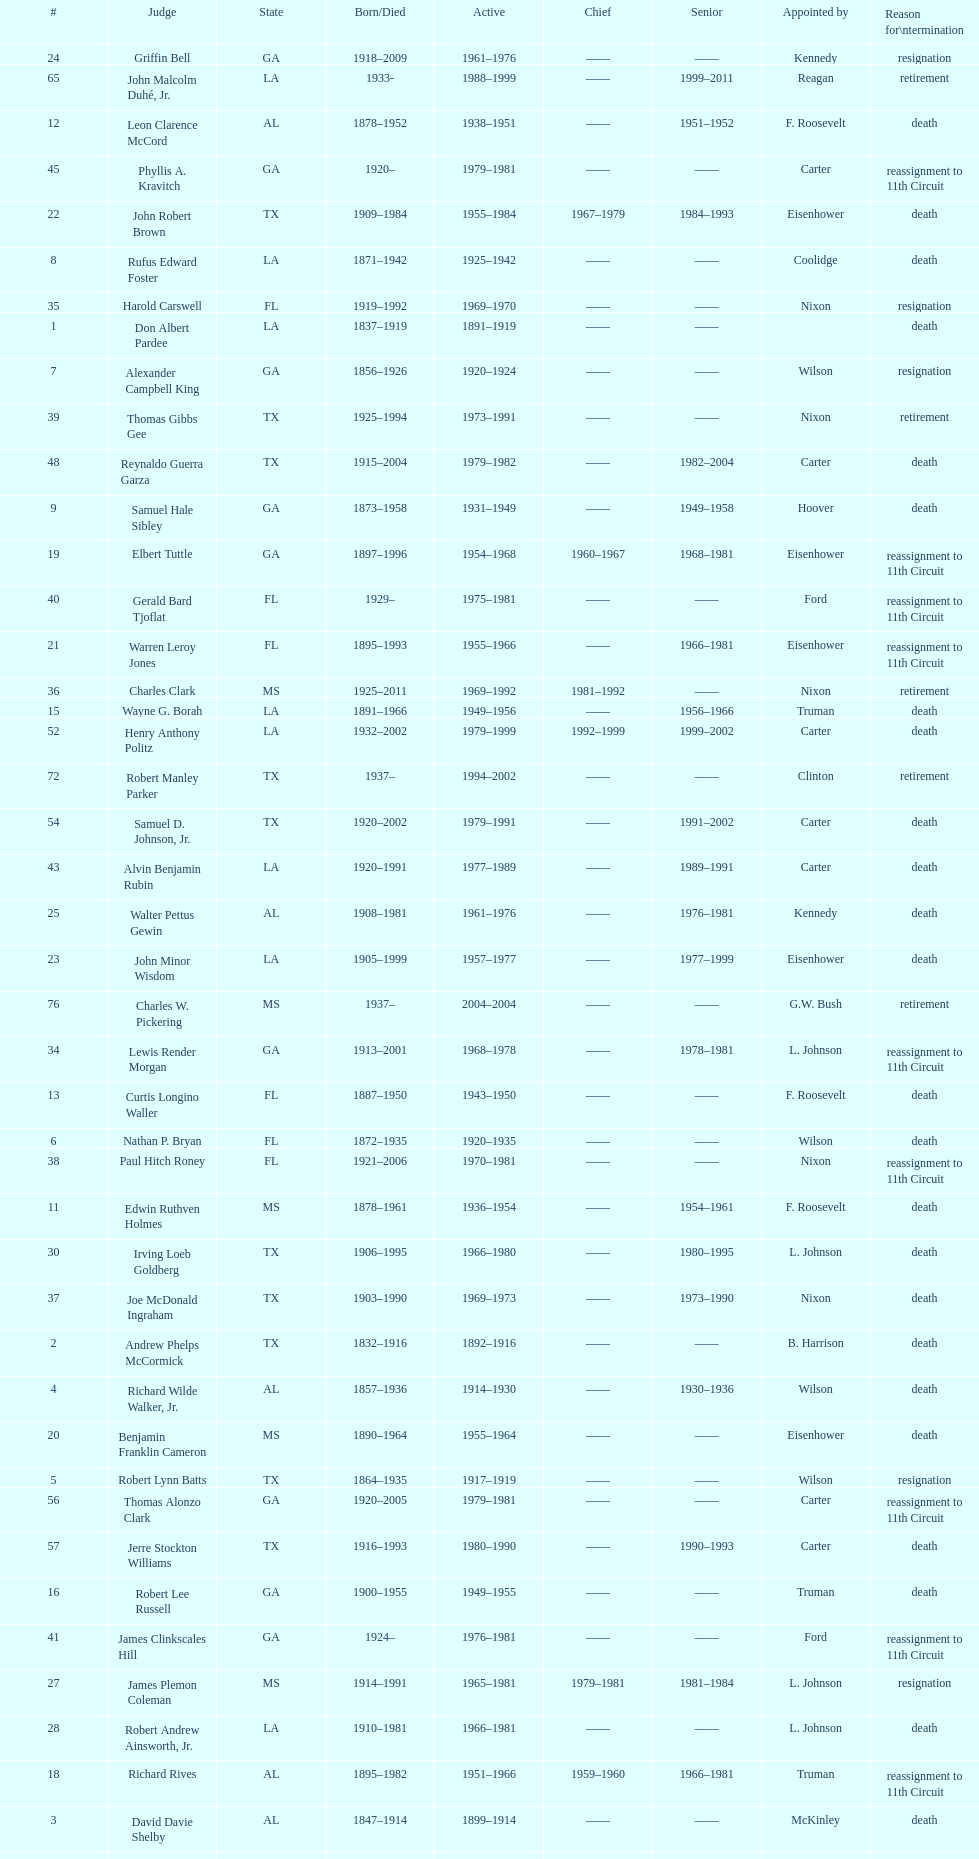Who was the only judge appointed by mckinley? David Davie Shelby. 